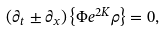<formula> <loc_0><loc_0><loc_500><loc_500>\left ( \partial _ { t } \pm \partial _ { x } \right ) \left \{ \Phi e ^ { 2 K } \rho \right \} = 0 ,</formula> 